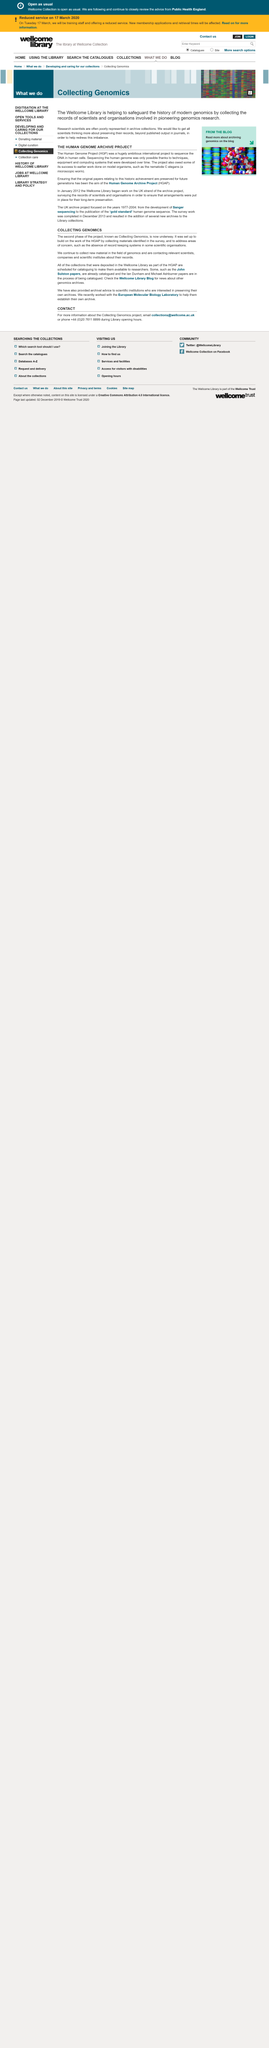Outline some significant characteristics in this image. The Human Genome Archive Project aimed to archive papers for future generations. The second phase of the project is known as Collecting Genomics. The Human Genome Project was a project that aimed to sequence the DNA in human cells. This project was one of the most significant scientific endeavors of the 20th century and revolutionized our understanding of genetics and human biology. The absence of a record keeping system in some scientific organizations is a matter of concern. The authors of the text are still collecting new material in the field of genomics. 